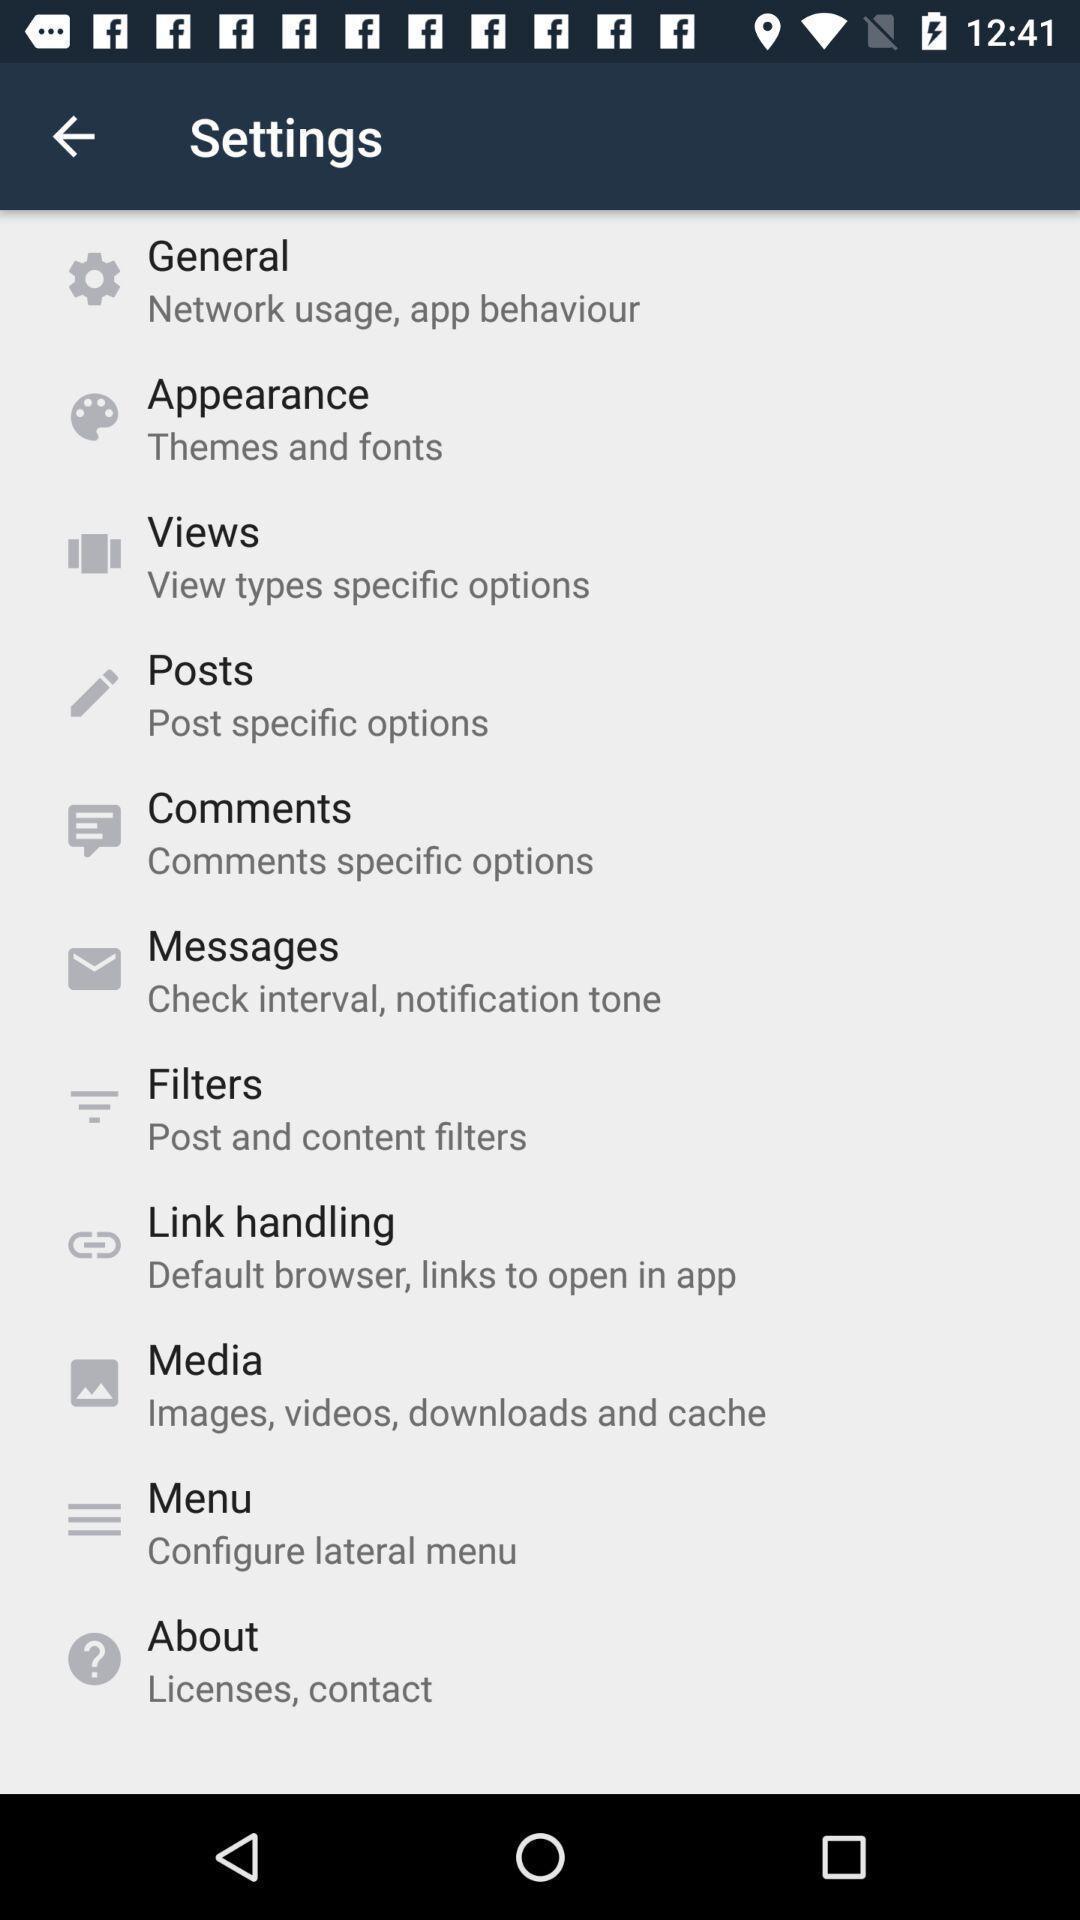Provide a description of this screenshot. Settings page. 